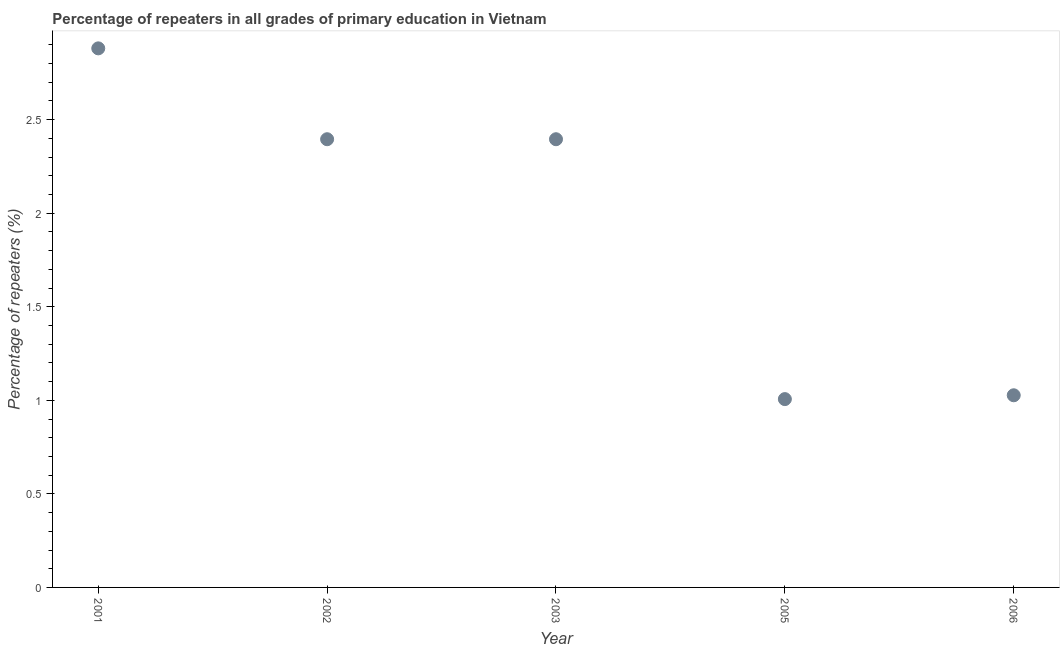What is the percentage of repeaters in primary education in 2005?
Make the answer very short. 1.01. Across all years, what is the maximum percentage of repeaters in primary education?
Give a very brief answer. 2.88. Across all years, what is the minimum percentage of repeaters in primary education?
Offer a terse response. 1.01. In which year was the percentage of repeaters in primary education maximum?
Make the answer very short. 2001. In which year was the percentage of repeaters in primary education minimum?
Ensure brevity in your answer.  2005. What is the sum of the percentage of repeaters in primary education?
Your response must be concise. 9.7. What is the difference between the percentage of repeaters in primary education in 2002 and 2006?
Provide a short and direct response. 1.37. What is the average percentage of repeaters in primary education per year?
Ensure brevity in your answer.  1.94. What is the median percentage of repeaters in primary education?
Your answer should be compact. 2.4. In how many years, is the percentage of repeaters in primary education greater than 2.7 %?
Give a very brief answer. 1. What is the ratio of the percentage of repeaters in primary education in 2001 to that in 2006?
Keep it short and to the point. 2.81. Is the percentage of repeaters in primary education in 2003 less than that in 2005?
Offer a very short reply. No. What is the difference between the highest and the second highest percentage of repeaters in primary education?
Offer a very short reply. 0.49. Is the sum of the percentage of repeaters in primary education in 2001 and 2005 greater than the maximum percentage of repeaters in primary education across all years?
Your answer should be very brief. Yes. What is the difference between the highest and the lowest percentage of repeaters in primary education?
Your answer should be very brief. 1.87. In how many years, is the percentage of repeaters in primary education greater than the average percentage of repeaters in primary education taken over all years?
Provide a succinct answer. 3. How many years are there in the graph?
Offer a terse response. 5. Are the values on the major ticks of Y-axis written in scientific E-notation?
Ensure brevity in your answer.  No. Does the graph contain grids?
Your response must be concise. No. What is the title of the graph?
Make the answer very short. Percentage of repeaters in all grades of primary education in Vietnam. What is the label or title of the X-axis?
Offer a terse response. Year. What is the label or title of the Y-axis?
Provide a succinct answer. Percentage of repeaters (%). What is the Percentage of repeaters (%) in 2001?
Offer a terse response. 2.88. What is the Percentage of repeaters (%) in 2002?
Provide a succinct answer. 2.4. What is the Percentage of repeaters (%) in 2003?
Your response must be concise. 2.4. What is the Percentage of repeaters (%) in 2005?
Keep it short and to the point. 1.01. What is the Percentage of repeaters (%) in 2006?
Offer a terse response. 1.03. What is the difference between the Percentage of repeaters (%) in 2001 and 2002?
Your answer should be very brief. 0.49. What is the difference between the Percentage of repeaters (%) in 2001 and 2003?
Ensure brevity in your answer.  0.49. What is the difference between the Percentage of repeaters (%) in 2001 and 2005?
Offer a terse response. 1.87. What is the difference between the Percentage of repeaters (%) in 2001 and 2006?
Offer a very short reply. 1.85. What is the difference between the Percentage of repeaters (%) in 2002 and 2003?
Your response must be concise. 1e-5. What is the difference between the Percentage of repeaters (%) in 2002 and 2005?
Provide a short and direct response. 1.39. What is the difference between the Percentage of repeaters (%) in 2002 and 2006?
Your answer should be compact. 1.37. What is the difference between the Percentage of repeaters (%) in 2003 and 2005?
Give a very brief answer. 1.39. What is the difference between the Percentage of repeaters (%) in 2003 and 2006?
Make the answer very short. 1.37. What is the difference between the Percentage of repeaters (%) in 2005 and 2006?
Make the answer very short. -0.02. What is the ratio of the Percentage of repeaters (%) in 2001 to that in 2002?
Offer a very short reply. 1.2. What is the ratio of the Percentage of repeaters (%) in 2001 to that in 2003?
Your answer should be compact. 1.2. What is the ratio of the Percentage of repeaters (%) in 2001 to that in 2005?
Keep it short and to the point. 2.86. What is the ratio of the Percentage of repeaters (%) in 2001 to that in 2006?
Your answer should be compact. 2.81. What is the ratio of the Percentage of repeaters (%) in 2002 to that in 2003?
Your answer should be very brief. 1. What is the ratio of the Percentage of repeaters (%) in 2002 to that in 2005?
Provide a short and direct response. 2.38. What is the ratio of the Percentage of repeaters (%) in 2002 to that in 2006?
Your response must be concise. 2.33. What is the ratio of the Percentage of repeaters (%) in 2003 to that in 2005?
Provide a short and direct response. 2.38. What is the ratio of the Percentage of repeaters (%) in 2003 to that in 2006?
Your answer should be compact. 2.33. 